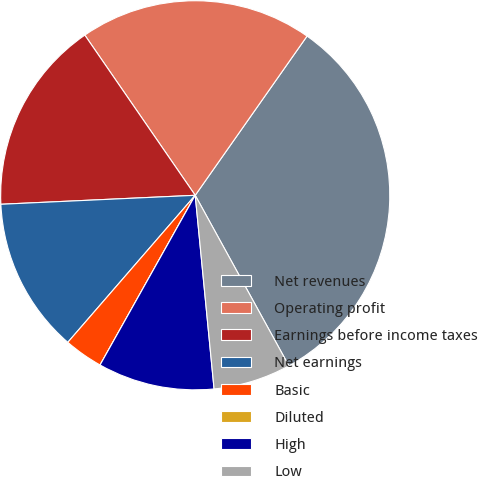<chart> <loc_0><loc_0><loc_500><loc_500><pie_chart><fcel>Net revenues<fcel>Operating profit<fcel>Earnings before income taxes<fcel>Net earnings<fcel>Basic<fcel>Diluted<fcel>High<fcel>Low<nl><fcel>32.26%<fcel>19.35%<fcel>16.13%<fcel>12.9%<fcel>3.23%<fcel>0.0%<fcel>9.68%<fcel>6.45%<nl></chart> 